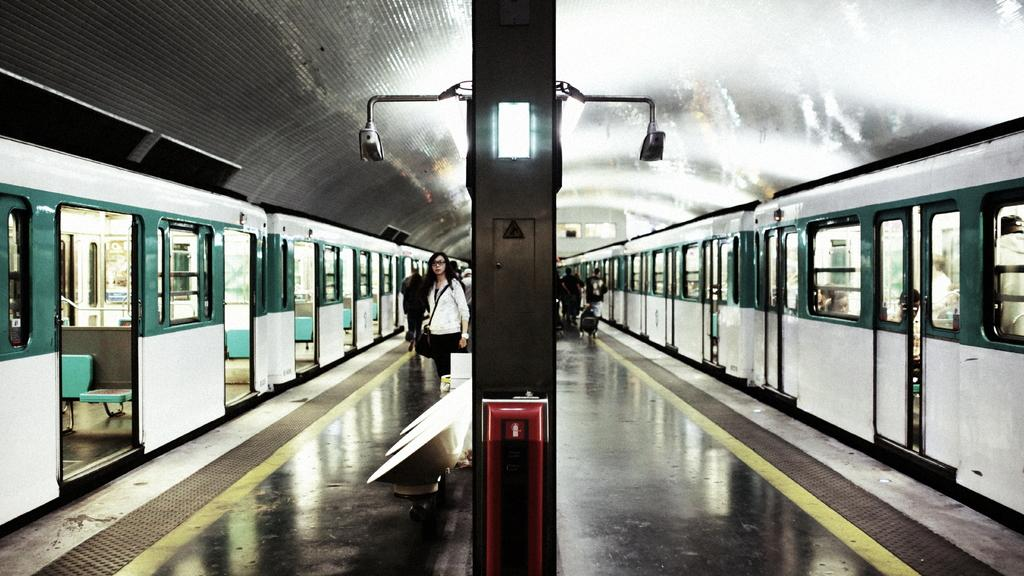What can be seen on the platform in the image? There are people on the platform in the image. What type of vehicles are visible in the image? There are trains visible in the image. What is used to illuminate the area in the image? Lights are attached to poles in the image. What type of seating is available in the image? Chairs are present in the image. What type of structure is present in the image? There is a shed in the image. What subject is being taught in the image? There is no indication of teaching or a classroom setting in the image. What type of coastline can be seen in the image? There is no coastline visible in the image; it features a platform with trains and people. 